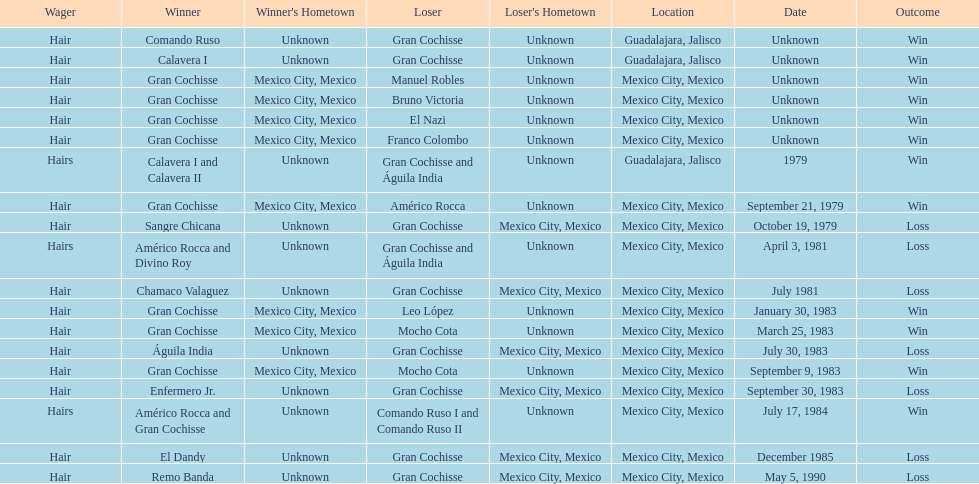How many winners were there before bruno victoria lost? 3. Help me parse the entirety of this table. {'header': ['Wager', 'Winner', "Winner's Hometown", 'Loser', "Loser's Hometown", 'Location', 'Date', 'Outcome'], 'rows': [['Hair', 'Comando Ruso', 'Unknown', 'Gran Cochisse', 'Unknown', 'Guadalajara, Jalisco', 'Unknown', 'Win'], ['Hair', 'Calavera I', 'Unknown', 'Gran Cochisse', 'Unknown', 'Guadalajara, Jalisco', 'Unknown', 'Win'], ['Hair', 'Gran Cochisse', 'Mexico City, Mexico', 'Manuel Robles', 'Unknown', 'Mexico City, Mexico', 'Unknown', 'Win'], ['Hair', 'Gran Cochisse', 'Mexico City, Mexico', 'Bruno Victoria', 'Unknown', 'Mexico City, Mexico', 'Unknown', 'Win'], ['Hair', 'Gran Cochisse', 'Mexico City, Mexico', 'El Nazi', 'Unknown', 'Mexico City, Mexico', 'Unknown', 'Win'], ['Hair', 'Gran Cochisse', 'Mexico City, Mexico', 'Franco Colombo', 'Unknown', 'Mexico City, Mexico', 'Unknown', 'Win'], ['Hairs', 'Calavera I and Calavera II', 'Unknown', 'Gran Cochisse and Águila India', 'Unknown', 'Guadalajara, Jalisco', '1979', 'Win'], ['Hair', 'Gran Cochisse', 'Mexico City, Mexico', 'Américo Rocca', 'Unknown', 'Mexico City, Mexico', 'September 21, 1979', 'Win'], ['Hair', 'Sangre Chicana', 'Unknown', 'Gran Cochisse', 'Mexico City, Mexico', 'Mexico City, Mexico', 'October 19, 1979', 'Loss'], ['Hairs', 'Américo Rocca and Divino Roy', 'Unknown', 'Gran Cochisse and Águila India', 'Unknown', 'Mexico City, Mexico', 'April 3, 1981', 'Loss'], ['Hair', 'Chamaco Valaguez', 'Unknown', 'Gran Cochisse', 'Mexico City, Mexico', 'Mexico City, Mexico', 'July 1981', 'Loss'], ['Hair', 'Gran Cochisse', 'Mexico City, Mexico', 'Leo López', 'Unknown', 'Mexico City, Mexico', 'January 30, 1983', 'Win'], ['Hair', 'Gran Cochisse', 'Mexico City, Mexico', 'Mocho Cota', 'Unknown', 'Mexico City, Mexico', 'March 25, 1983', 'Win'], ['Hair', 'Águila India', 'Unknown', 'Gran Cochisse', 'Mexico City, Mexico', 'Mexico City, Mexico', 'July 30, 1983', 'Loss'], ['Hair', 'Gran Cochisse', 'Mexico City, Mexico', 'Mocho Cota', 'Unknown', 'Mexico City, Mexico', 'September 9, 1983', 'Win'], ['Hair', 'Enfermero Jr.', 'Unknown', 'Gran Cochisse', 'Mexico City, Mexico', 'Mexico City, Mexico', 'September 30, 1983', 'Loss'], ['Hairs', 'Américo Rocca and Gran Cochisse', 'Unknown', 'Comando Ruso I and Comando Ruso II', 'Unknown', 'Mexico City, Mexico', 'July 17, 1984', 'Win'], ['Hair', 'El Dandy', 'Unknown', 'Gran Cochisse', 'Mexico City, Mexico', 'Mexico City, Mexico', 'December 1985', 'Loss'], ['Hair', 'Remo Banda', 'Unknown', 'Gran Cochisse', 'Mexico City, Mexico', 'Mexico City, Mexico', 'May 5, 1990', 'Loss']]} 